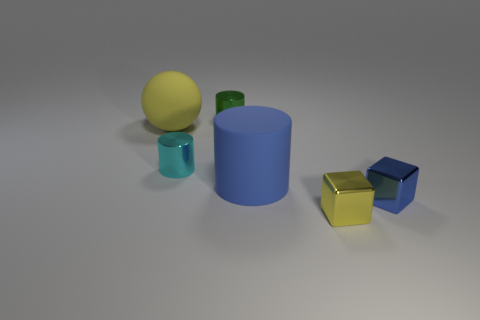There is a yellow metallic object; what number of blue things are in front of it?
Make the answer very short. 0. What number of other objects are the same shape as the large yellow matte thing?
Your answer should be compact. 0. Are there fewer big red metal spheres than tiny yellow objects?
Your answer should be compact. Yes. How big is the thing that is both behind the blue shiny block and to the right of the green thing?
Offer a terse response. Large. There is a cyan cylinder that is in front of the metal cylinder behind the yellow thing behind the cyan shiny object; what size is it?
Provide a succinct answer. Small. What is the size of the cyan cylinder?
Provide a short and direct response. Small. Are there any other things that are made of the same material as the blue cube?
Offer a terse response. Yes. Are there any big cylinders on the left side of the yellow thing that is behind the large thing that is to the right of the tiny green metal cylinder?
Your response must be concise. No. What number of small objects are spheres or cubes?
Ensure brevity in your answer.  2. Is there anything else that has the same color as the sphere?
Keep it short and to the point. Yes. 